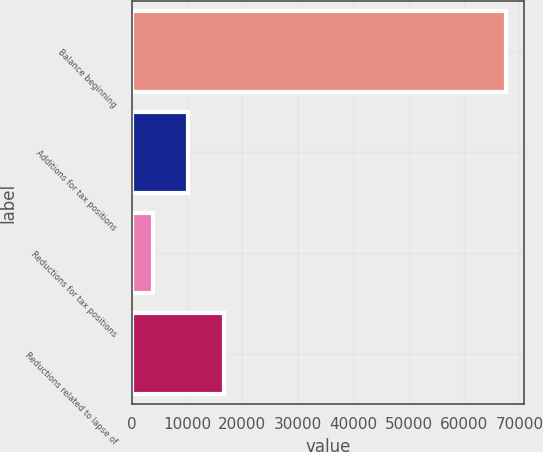Convert chart to OTSL. <chart><loc_0><loc_0><loc_500><loc_500><bar_chart><fcel>Balance beginning<fcel>Additions for tax positions<fcel>Reductions for tax positions<fcel>Reductions related to lapse of<nl><fcel>67546<fcel>10265.5<fcel>3901<fcel>16630<nl></chart> 